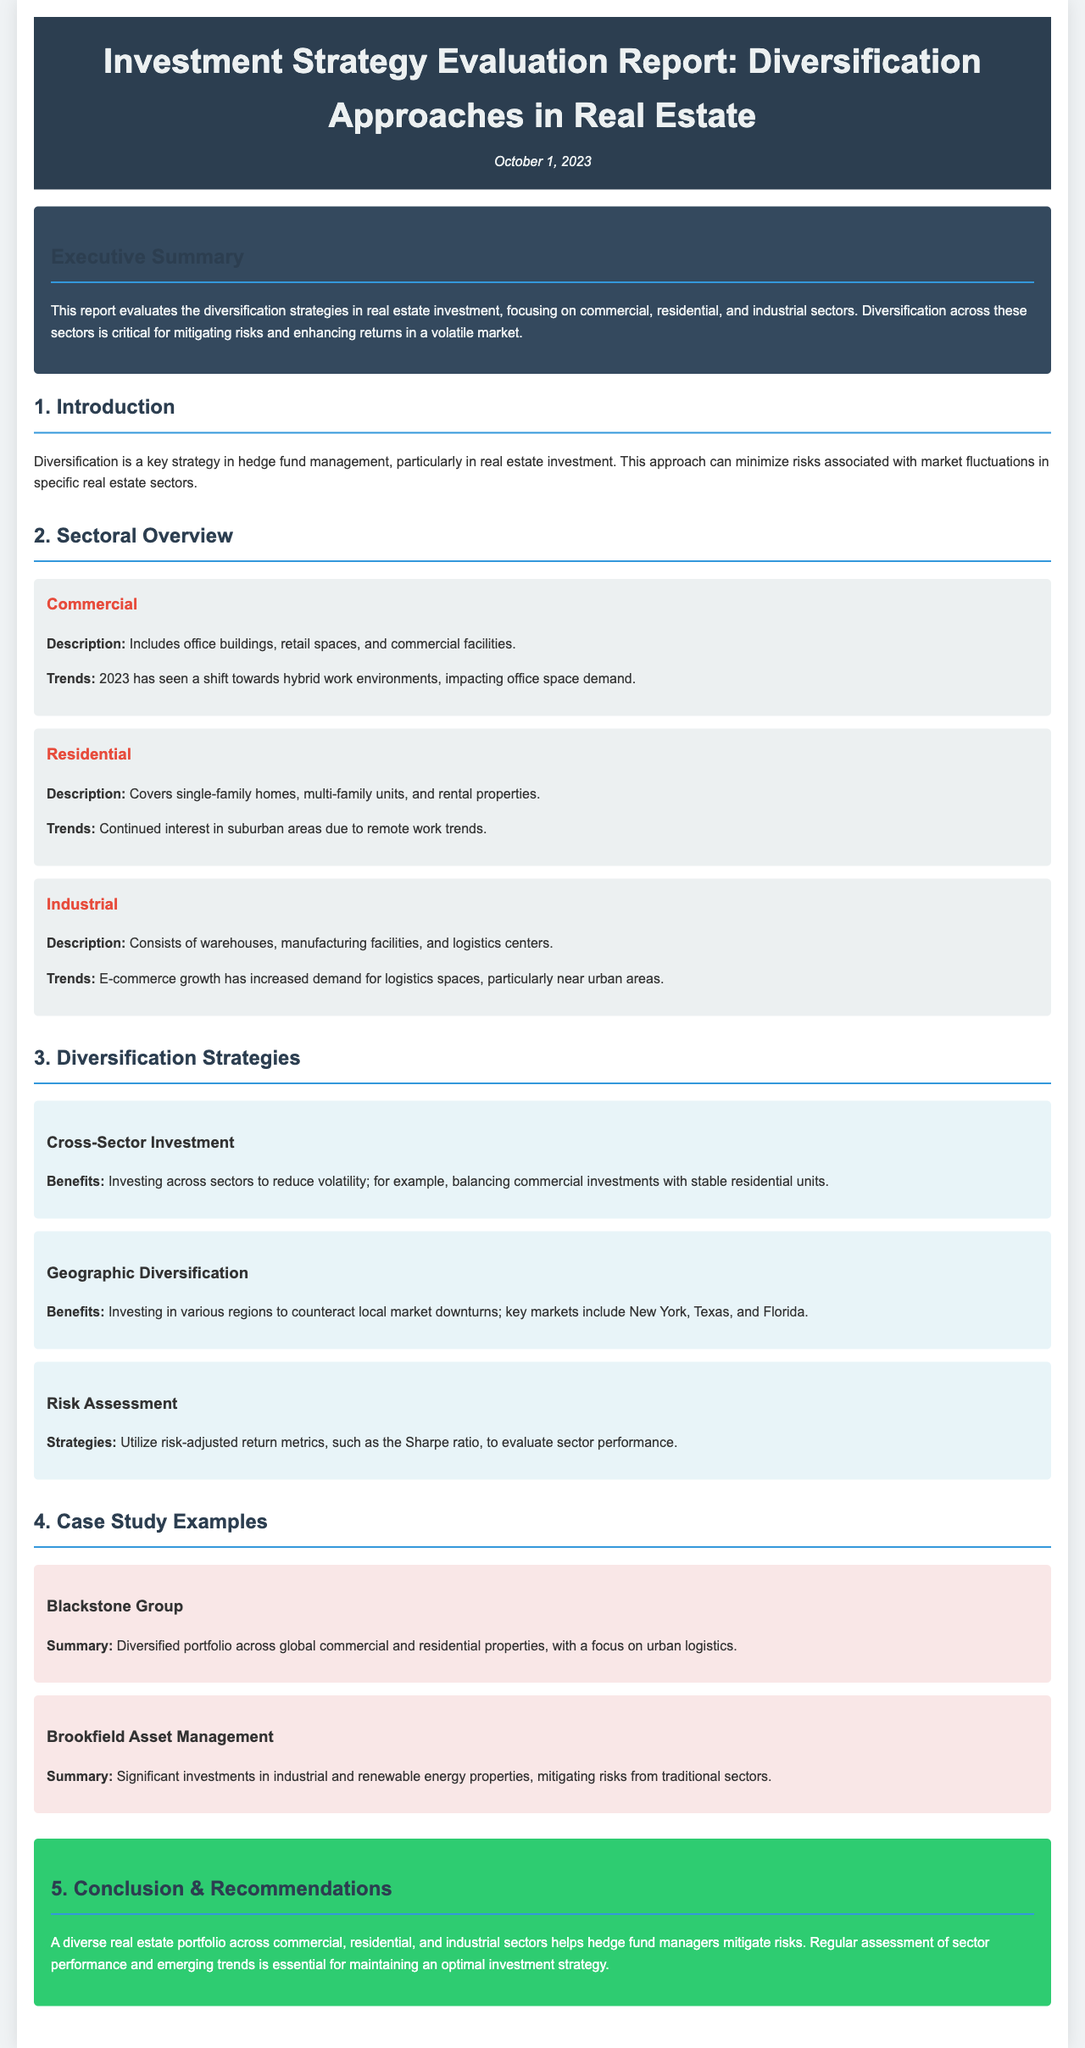What is the date of the report? The date is mentioned at the top of the document under the title in the header section.
Answer: October 1, 2023 What sectors are covered in the report? The document outlines three specific sectors in the sector overview section.
Answer: Commercial, Residential, Industrial What is one key trend impacting the commercial sector in 2023? The trends for the commercial sector are described in the sector section, specifically addressing office space demand.
Answer: Hybrid work environments What strategy involves investing in different geographic areas? The diversification strategies section discusses this particular strategy that counters local downturns.
Answer: Geographic Diversification Who is one of the case study examples mentioned in the report? The case studies highlight examples of well-known firms and their strategies within the document.
Answer: Blackstone Group What metrics are suggested for risk assessment? The report provides specific metrics used to evaluate performance in the risk assessment section.
Answer: Sharpe ratio What is the primary conclusion of the report? The conclusion summarizes the main finding and recommendation of diversifying across different sectors in real estate.
Answer: Mitigate risks What type of investment does "Cross-Sector Investment" refer to? The diversification strategy describes this investment type across various sectors to reduce volatility.
Answer: Diversification across sectors 